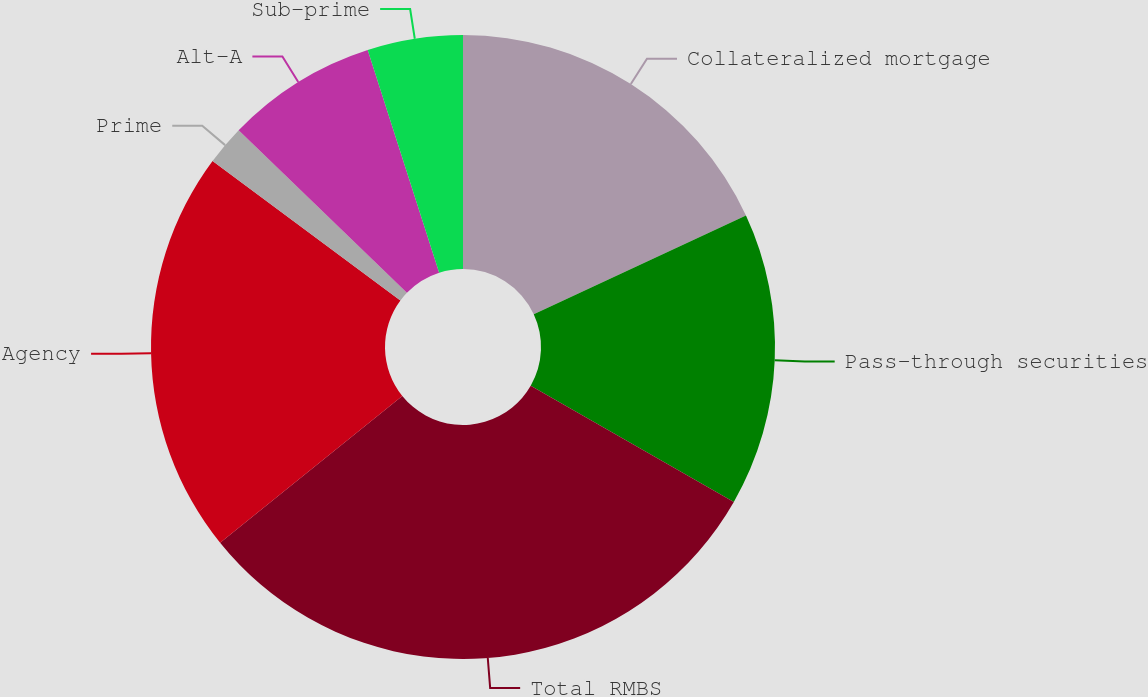<chart> <loc_0><loc_0><loc_500><loc_500><pie_chart><fcel>Collateralized mortgage<fcel>Pass-through securities<fcel>Total RMBS<fcel>Agency<fcel>Prime<fcel>Alt-A<fcel>Sub-prime<nl><fcel>18.08%<fcel>15.19%<fcel>30.93%<fcel>20.97%<fcel>2.06%<fcel>7.83%<fcel>4.94%<nl></chart> 